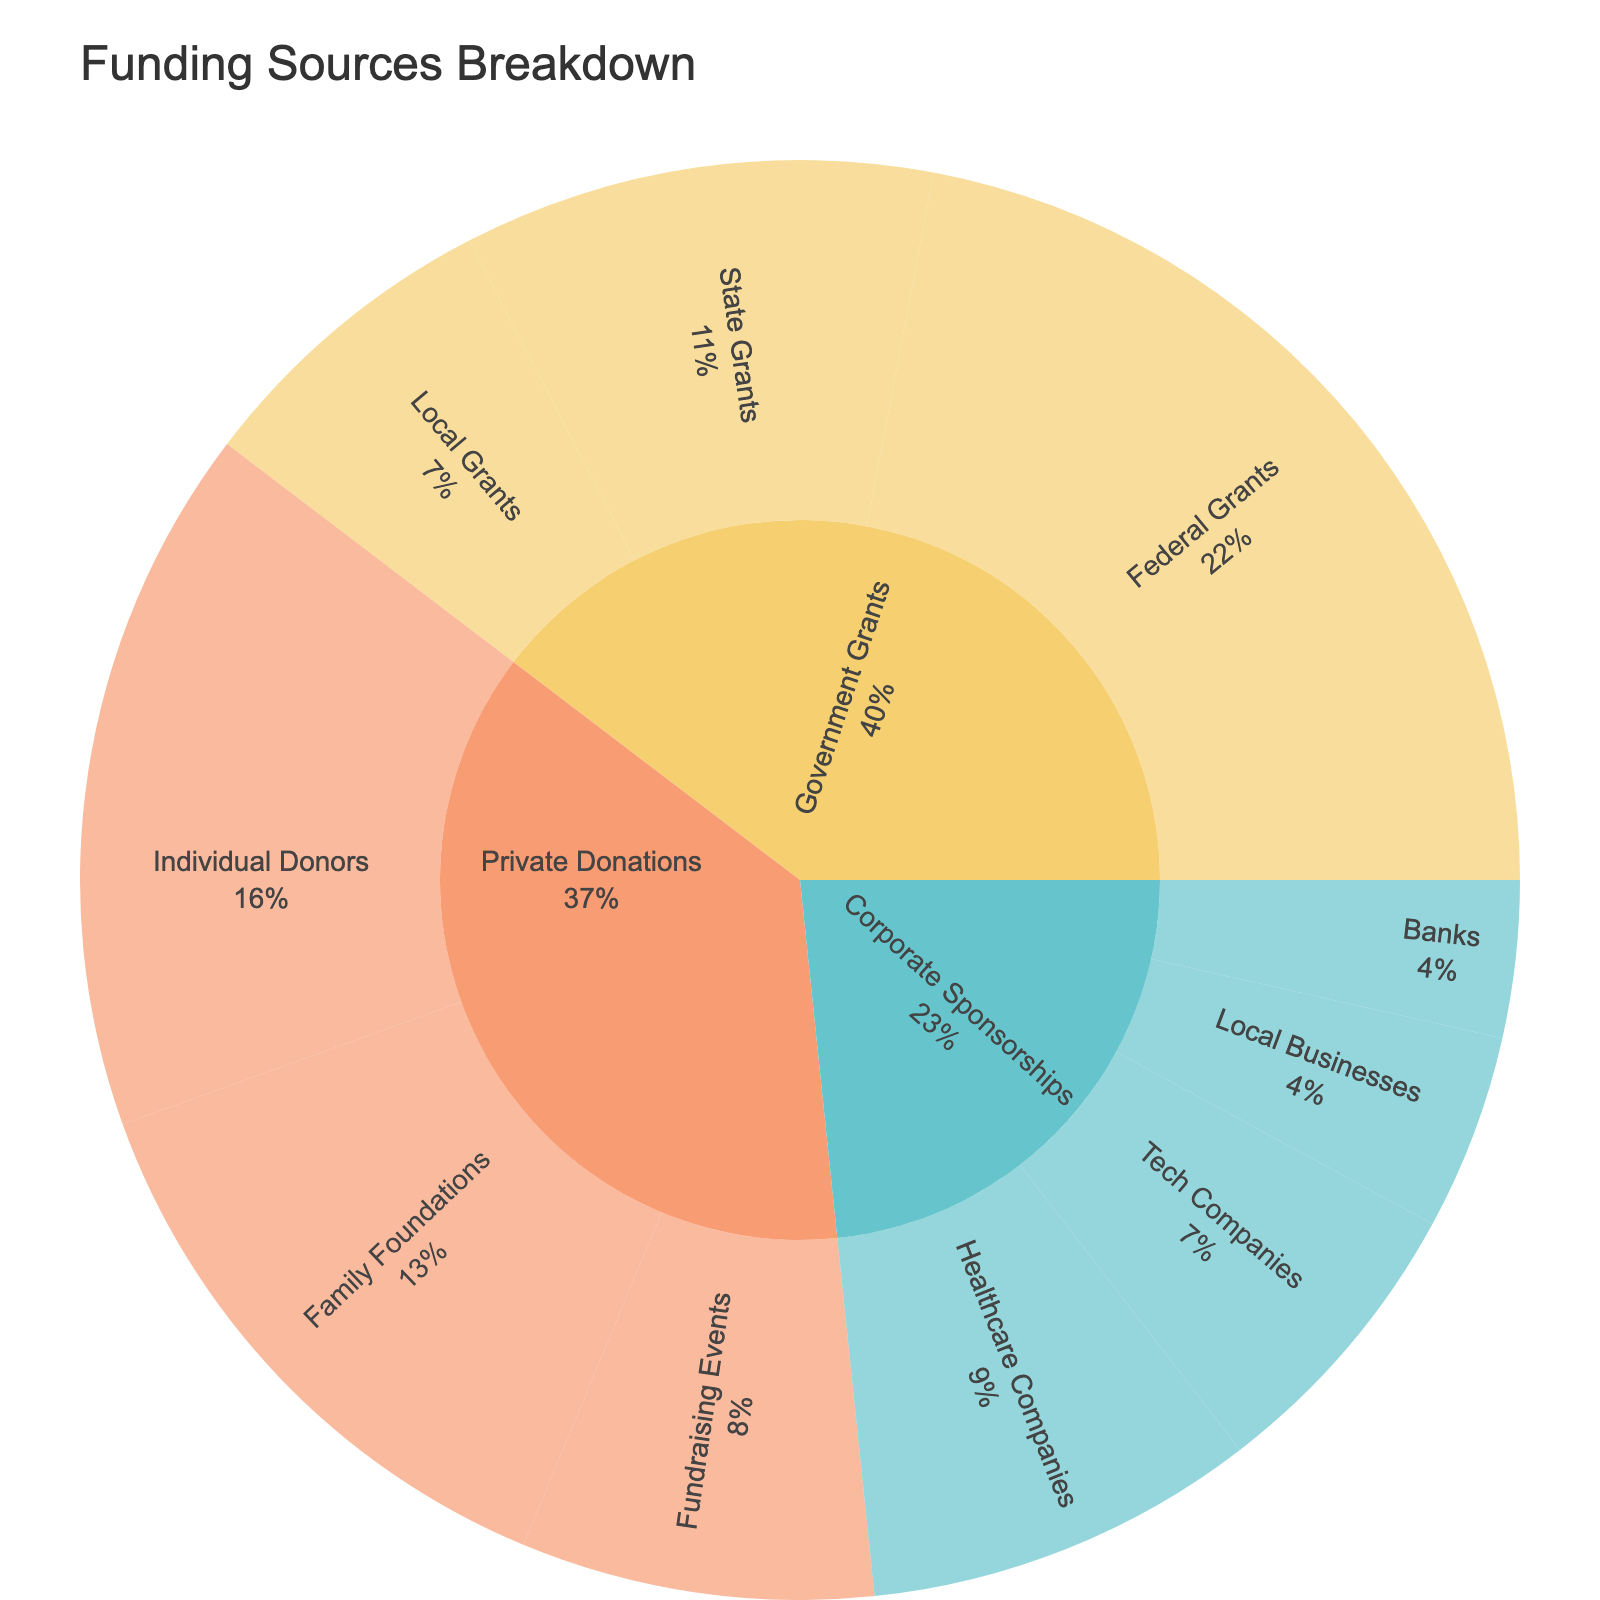What is the total amount received from Federal Grants? The outer ring of the sunburst plot shows that Federal Grants contributed $250,000 to the total funding.
Answer: $250,000 Which category received higher funding, Private Donations or Corporate Sponsorships? By comparing the sum of the amounts, Private Donations received ($180,000 + $150,000 + $90,000) = $420,000, and Corporate Sponsorships received ($100,000 + $75,000 + $50,000 + $40,000) = $265,000. Therefore, Private Donations received higher funding.
Answer: Private Donations What percentage of funding comes from Government Grants? The sunburst plot's text includes percentage information. Adding contributions from all subcategories within Government Grants ($250,000 + $120,000 + $80,000), the total is $450,000. This amount forms a percentage of the total funding.
Answer: 39.1% Which subcategory received the lowest amount of funding? By inspecting the smallest segments on the outer ring, Banks under Corporate Sponsorships received the lowest funding with $40,000.
Answer: Banks What's the difference in amount between Individual Donors and Tech Companies? Individual Donors contributed $180,000 and Tech Companies contributed $75,000. The difference is calculated as $180,000 - $75,000.
Answer: $105,000 How much funding is contributed by Local Businesses and Banks combined? Adding the funding from Local Businesses ($50,000) and Banks ($40,000), the combined total is $50,000 + $40,000.
Answer: $90,000 Which category has the most subcategories? By visual inspection, Corporate Sponsorships has four subcategories: Healthcare Companies, Tech Companies, Local Businesses, and Banks.
Answer: Corporate Sponsorships What is the total funding amount from all sources? Sum all subcategories: $250,000 (Federal Grants) + $120,000 (State Grants) + $80,000 (Local Grants) + $180,000 (Individual Donors) + $150,000 (Family Foundations) + $90,000 (Fundraising Events) + $100,000 (Healthcare Companies) + $75,000 (Tech Companies) + $50,000 (Local Businesses) + $40,000 (Banks). The total is $1,135,000.
Answer: $1,135,000 How does funding from Healthcare Companies compare to funding from State Grants? Healthcare Companies contributed $100,000 and State Grants contributed $120,000. Comparatively, State Grants received more funding.
Answer: State Grants received more Which subcategory within Private Donations received the highest funding? By examining the subcategories under Private Donations, Individual Donors contributed the highest amount with $180,000.
Answer: Individual Donors 